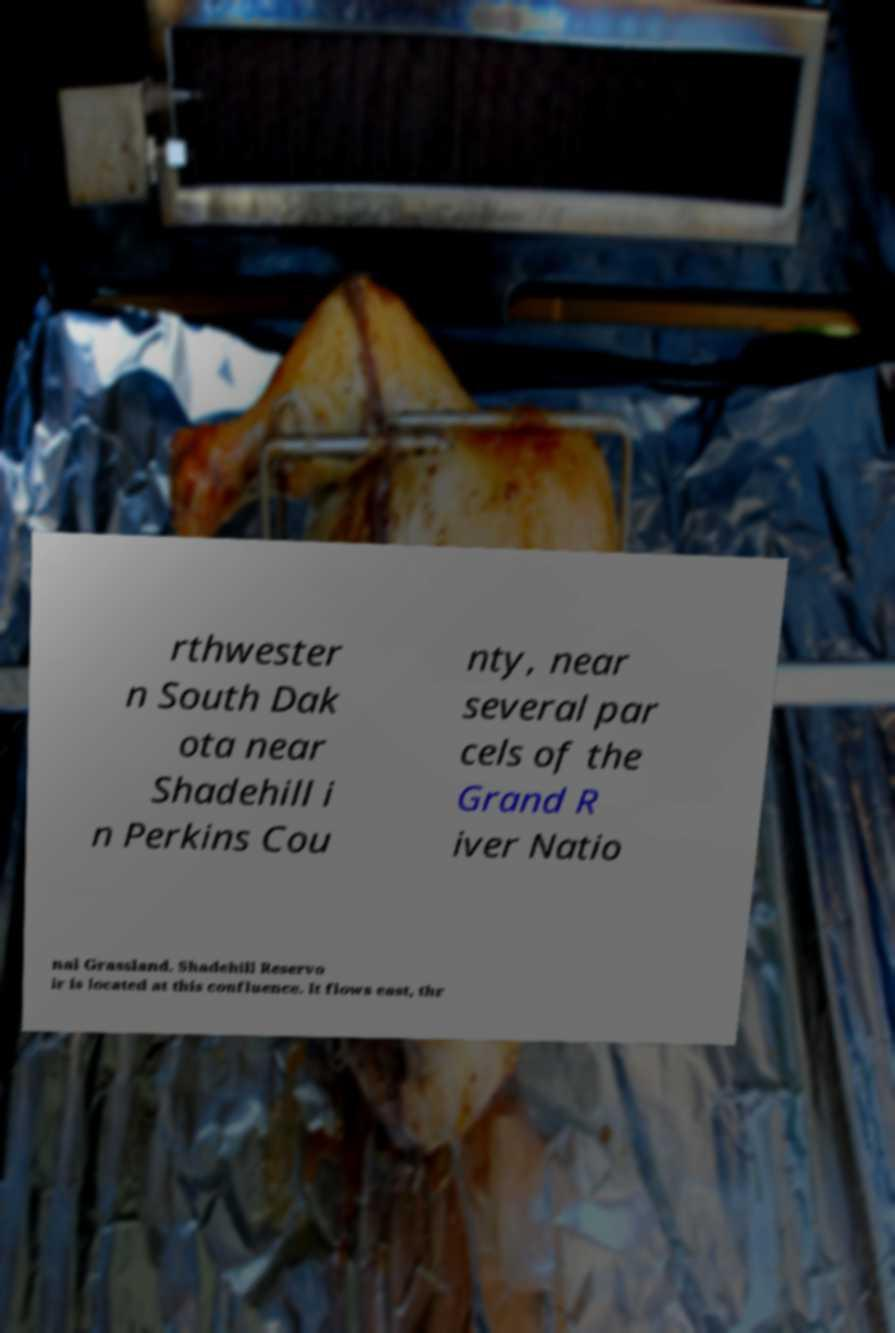There's text embedded in this image that I need extracted. Can you transcribe it verbatim? rthwester n South Dak ota near Shadehill i n Perkins Cou nty, near several par cels of the Grand R iver Natio nal Grassland. Shadehill Reservo ir is located at this confluence. It flows east, thr 